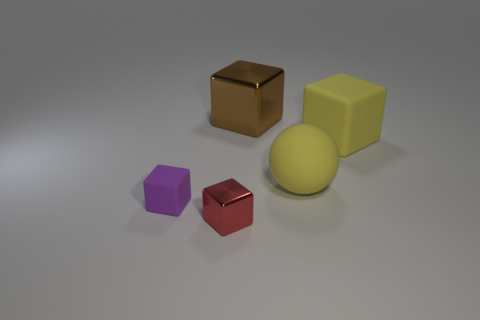Is there any other thing that is the same shape as the red thing?
Your response must be concise. Yes. What is the color of the block that is on the right side of the tiny red metallic thing and in front of the brown shiny block?
Offer a terse response. Yellow. What number of blocks are either brown rubber things or tiny red shiny objects?
Your answer should be very brief. 1. How many metallic blocks have the same size as the yellow sphere?
Make the answer very short. 1. There is a shiny cube that is left of the brown metallic cube; what number of matte cubes are left of it?
Keep it short and to the point. 1. How big is the thing that is on the right side of the big brown object and behind the yellow rubber ball?
Provide a succinct answer. Large. Are there more gray matte blocks than brown shiny cubes?
Your answer should be compact. No. Is there a shiny block of the same color as the large sphere?
Offer a very short reply. No. There is a shiny thing that is behind the red metal thing; is its size the same as the yellow ball?
Your answer should be compact. Yes. Is the number of large yellow objects less than the number of big metal objects?
Provide a short and direct response. No. 